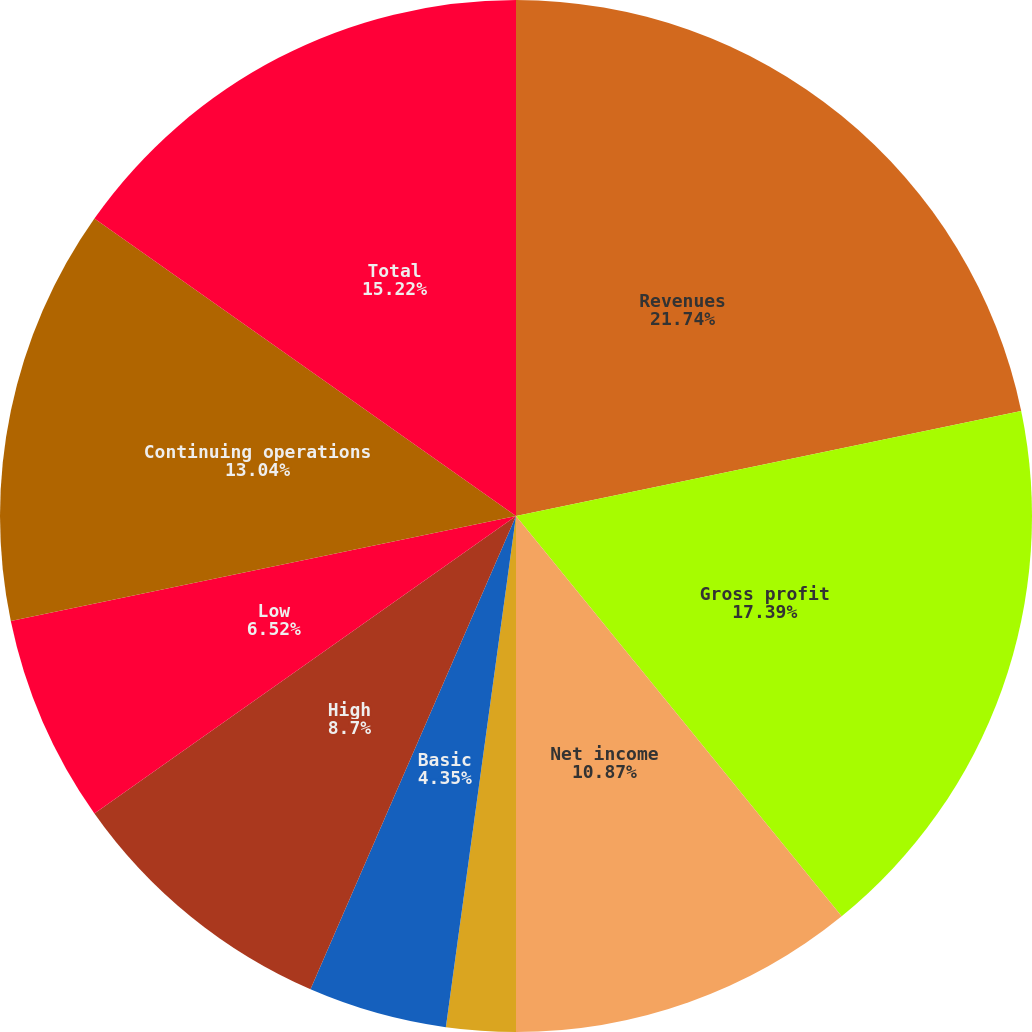Convert chart. <chart><loc_0><loc_0><loc_500><loc_500><pie_chart><fcel>Revenues<fcel>Gross profit<fcel>Net income<fcel>Diluted<fcel>Basic<fcel>Cash dividends per common<fcel>High<fcel>Low<fcel>Continuing operations<fcel>Total<nl><fcel>21.74%<fcel>17.39%<fcel>10.87%<fcel>2.17%<fcel>4.35%<fcel>0.0%<fcel>8.7%<fcel>6.52%<fcel>13.04%<fcel>15.22%<nl></chart> 